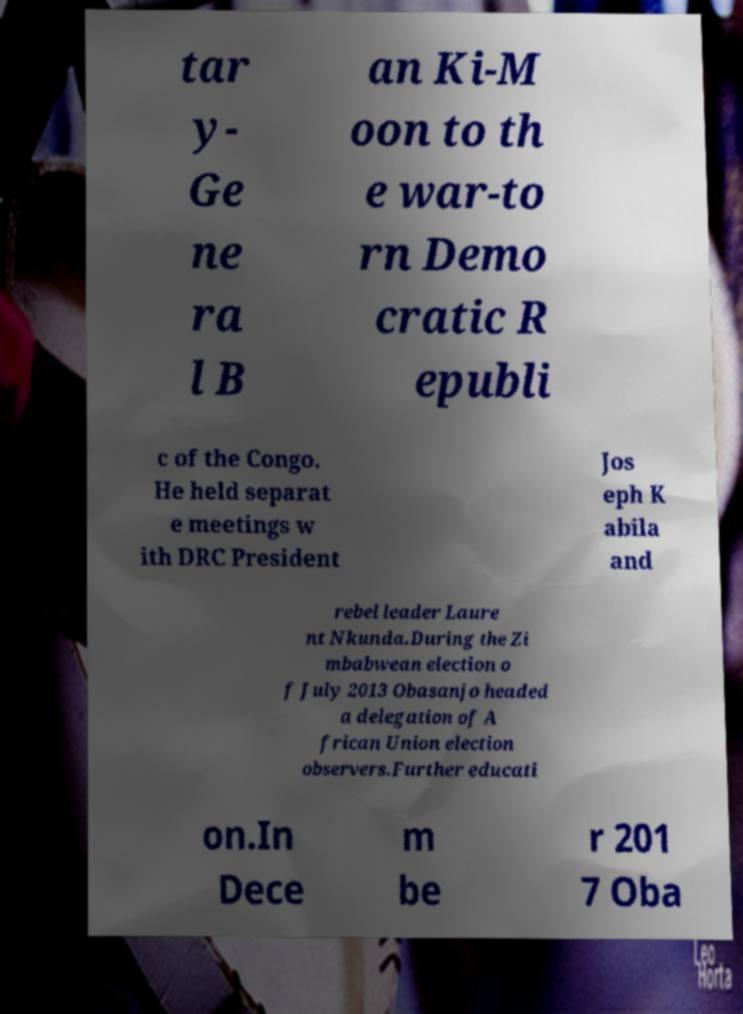Could you assist in decoding the text presented in this image and type it out clearly? tar y- Ge ne ra l B an Ki-M oon to th e war-to rn Demo cratic R epubli c of the Congo. He held separat e meetings w ith DRC President Jos eph K abila and rebel leader Laure nt Nkunda.During the Zi mbabwean election o f July 2013 Obasanjo headed a delegation of A frican Union election observers.Further educati on.In Dece m be r 201 7 Oba 